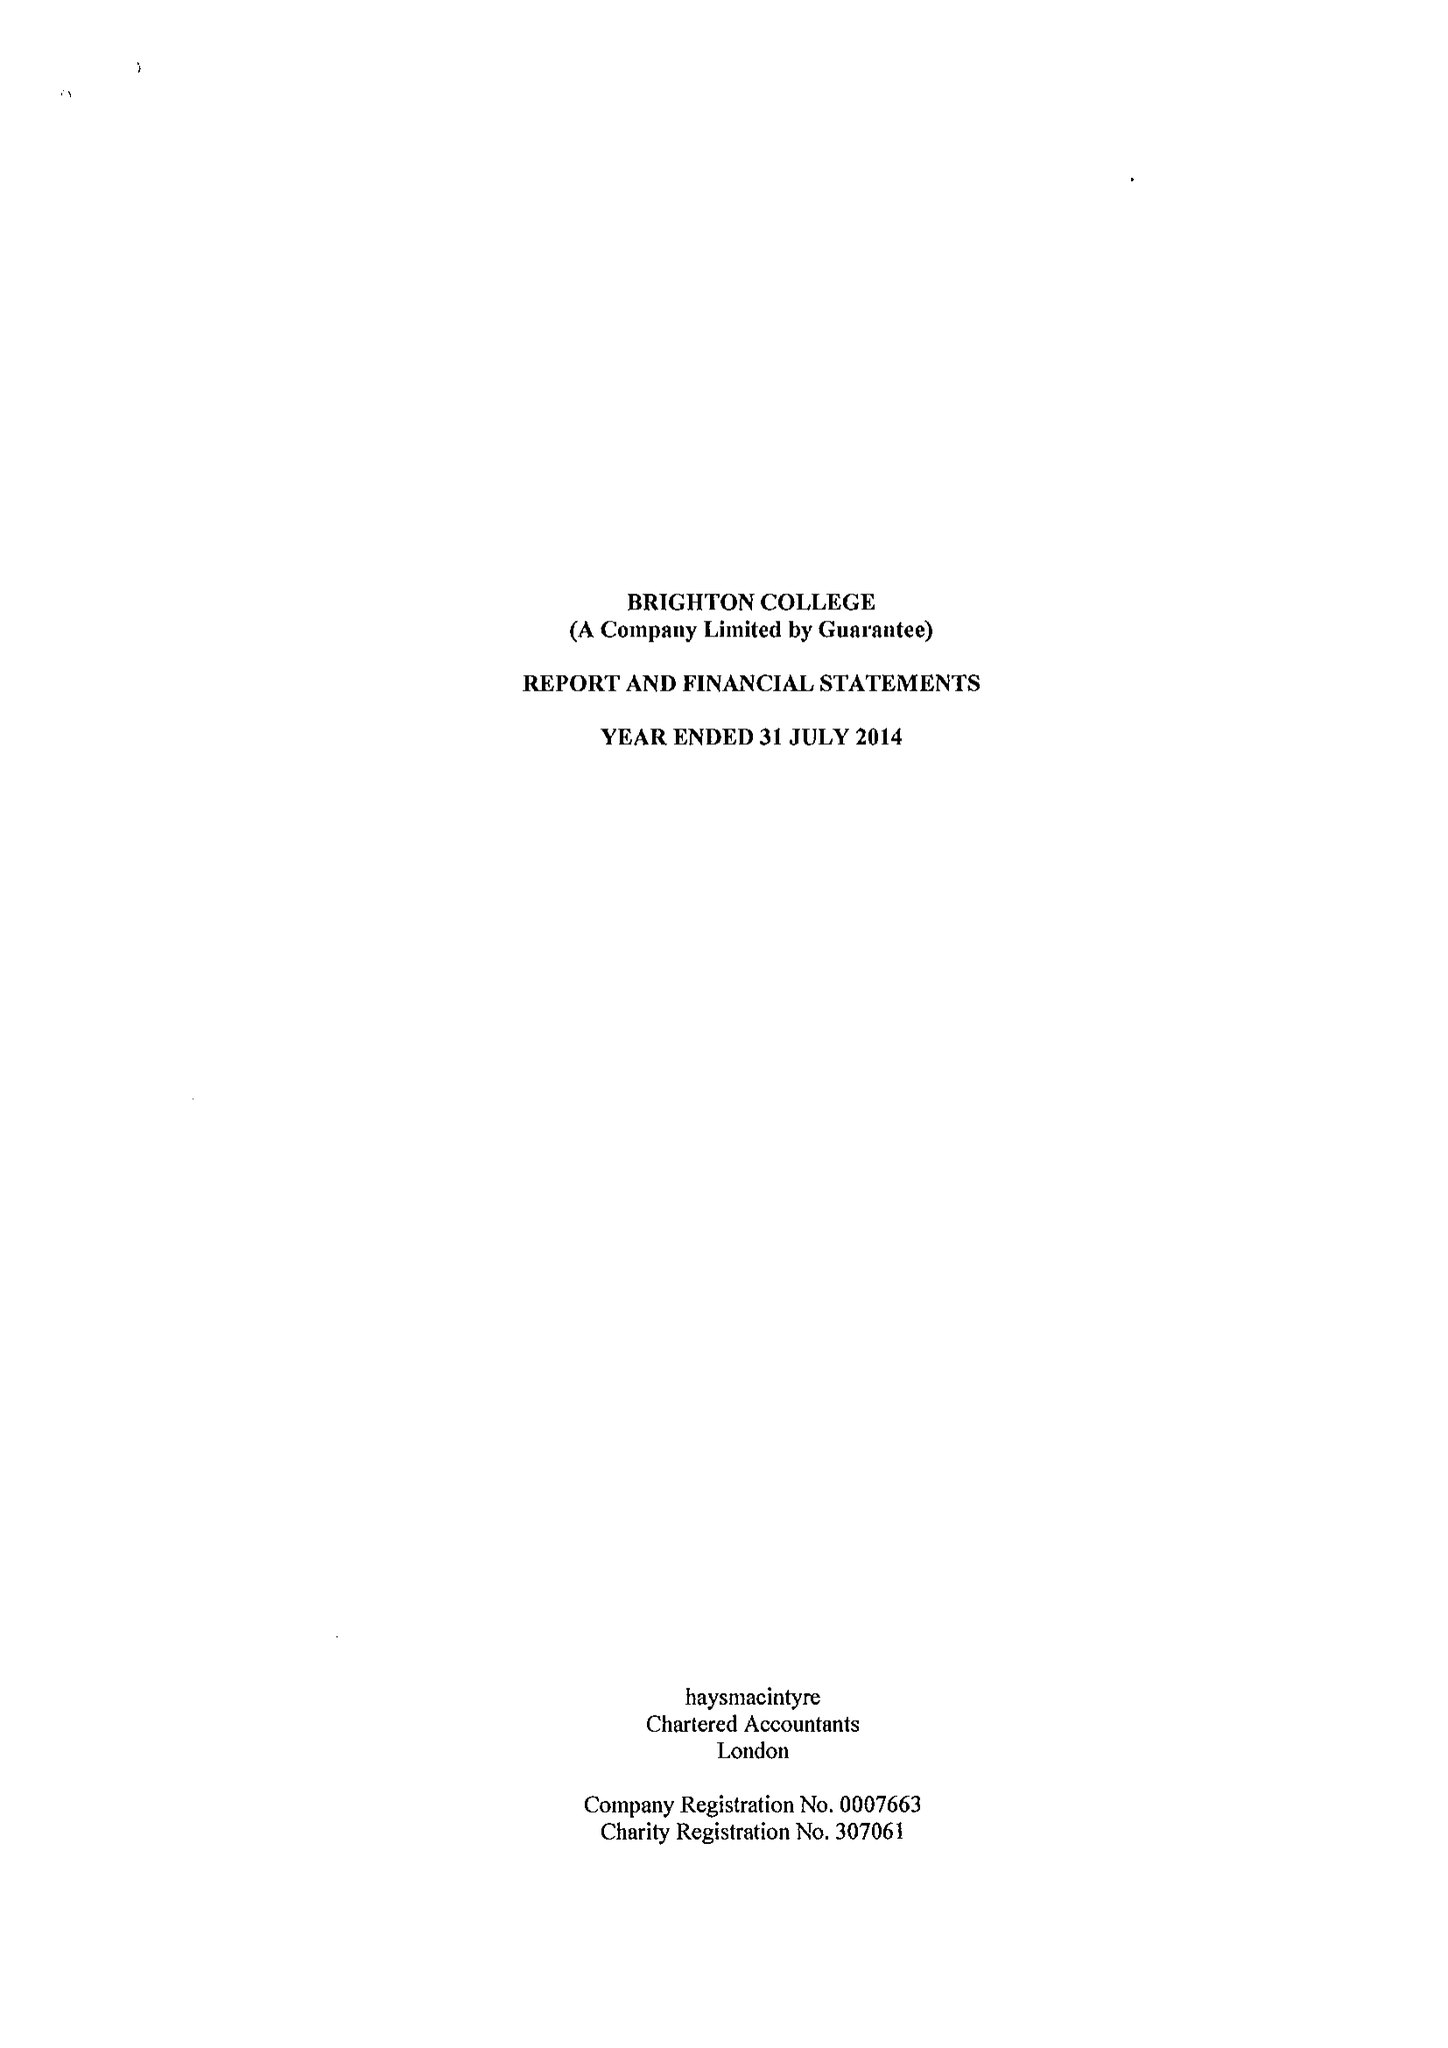What is the value for the address__postcode?
Answer the question using a single word or phrase. BN2 0AL 